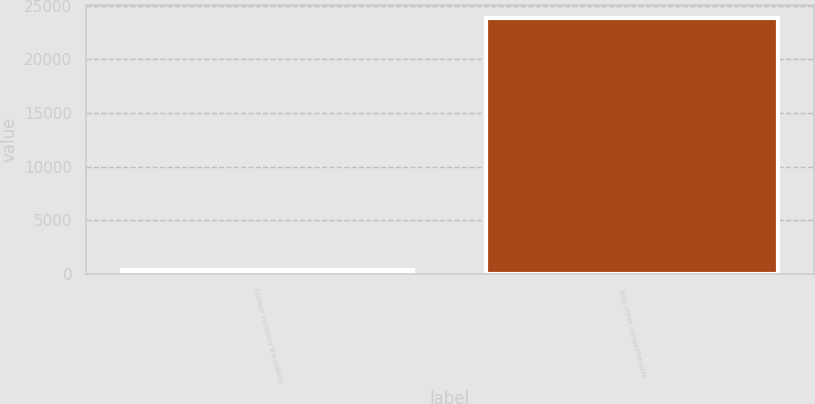<chart> <loc_0><loc_0><loc_500><loc_500><bar_chart><fcel>Foreign currency translation<fcel>Total other comprehensive<nl><fcel>359<fcel>23838<nl></chart> 